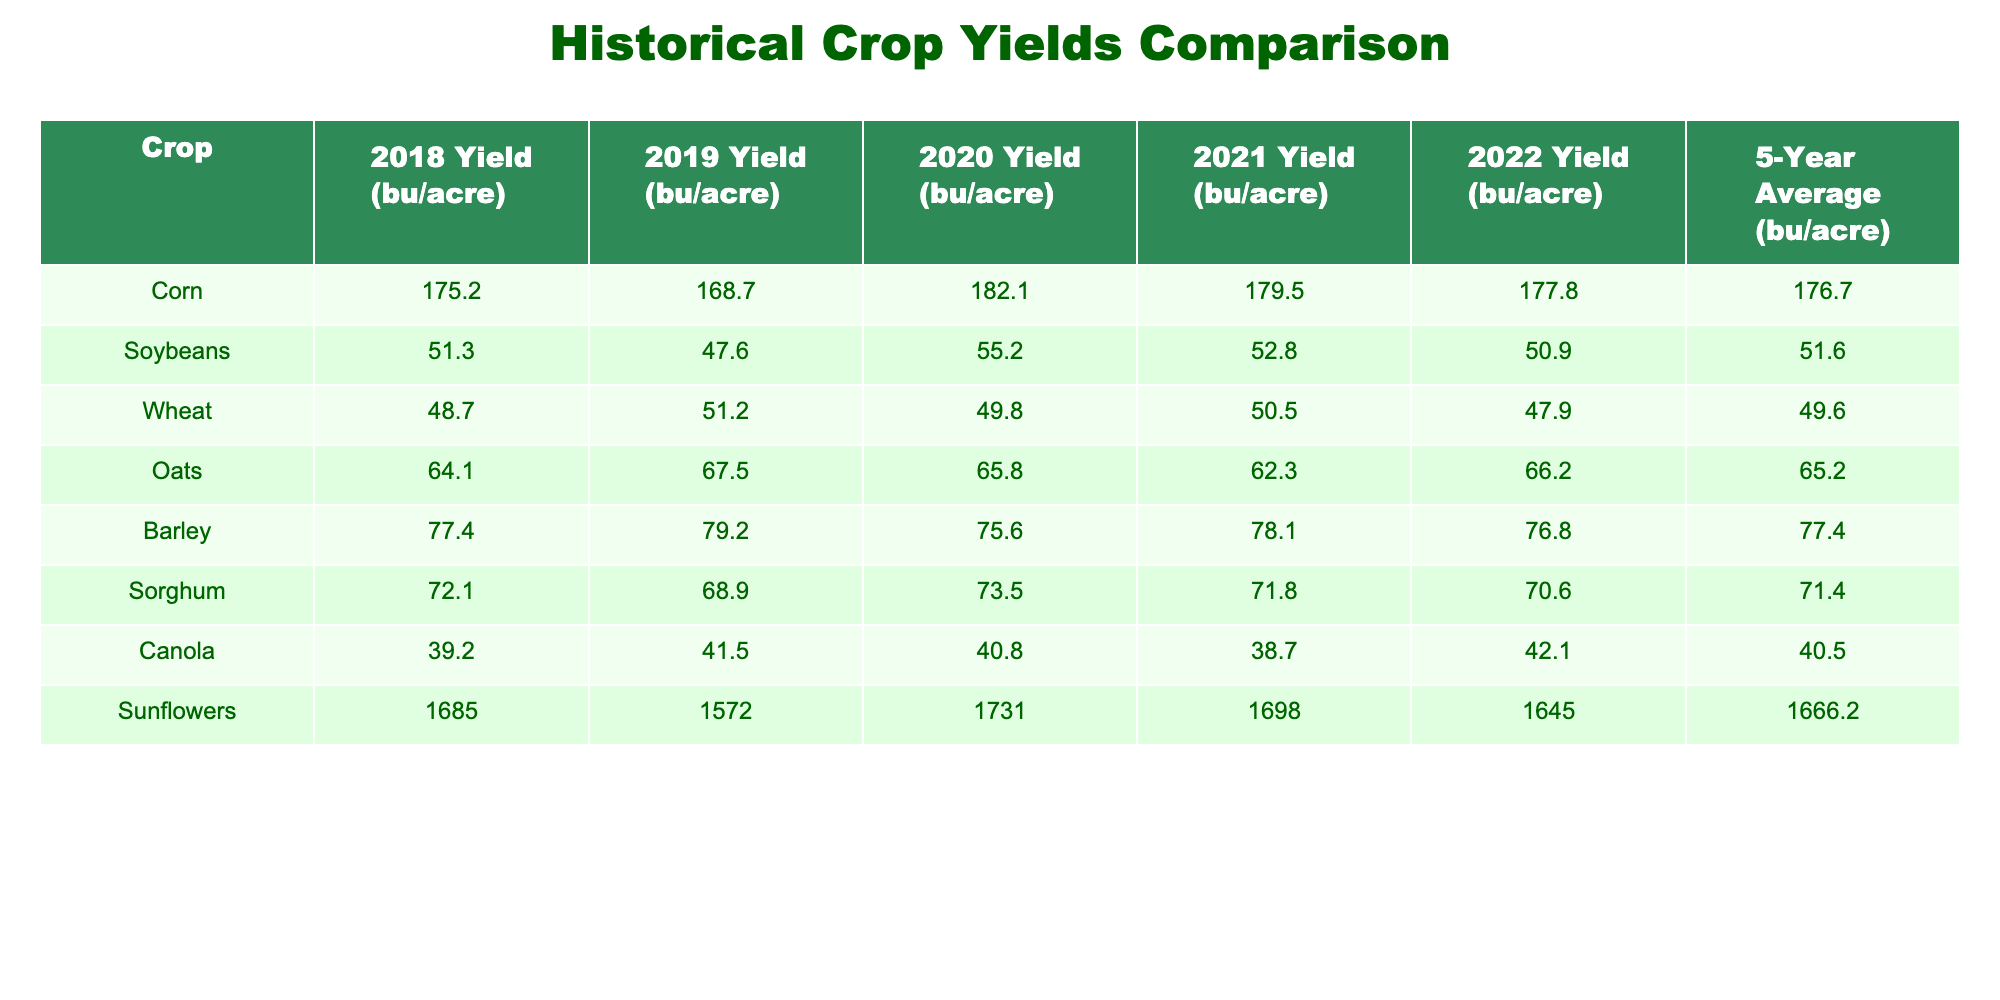What was the yield of corn in 2020? The table lists the yields for corn in each year. To find the yield in 2020, we look under the "2020 Yield (bu/acre)" column for corn, which shows 182.1.
Answer: 182.1 Which crop had the highest average yield over the 5 years? We need to compare the 5-Year Average yields for all crops listed in the table. The average yields are: Corn 176.7, Soybeans 51.6, Wheat 49.6, Oats 65.2, Barley 77.4, Sorghum 71.4, Canola 40.5, and Sunflowers 1666.2. Among these, Sunflowers have the highest yield at 1666.2.
Answer: Sunflowers Is the average yield of wheat greater than that of sorghum? The table shows the 5-Year Average yields: Wheat has 49.6, and Sorghum has 71.4. Since 49.6 is less than 71.4, the statement is false.
Answer: No What is the difference between the average yield of corn and the average yield of barley? From the table, the average yield for corn is 176.7, while for barley it is 77.4. To find the difference, we subtract the average yield of barley from that of corn: 176.7 - 77.4 = 99.3.
Answer: 99.3 In which year did soybeans have the lowest yield? To find the lowest yield for soybeans, we look at the annual yields in the table: 51.3 (2018), 47.6 (2019), 55.2 (2020), 52.8 (2021), and 50.9 (2022). The lowest yield is 47.6 in the year 2019.
Answer: 2019 What is the total yield of oats over the 5-year period? The yields for oats are: 64.1 (2018), 67.5 (2019), 65.8 (2020), 62.3 (2021), and 66.2 (2022). Summing these gives: 64.1 + 67.5 + 65.8 + 62.3 + 66.2 = 325.9.
Answer: 325.9 Did canola have a yield of more than 40 bu/acre in every year? We check the yields for canola: 39.2 (2018), 41.5 (2019), 40.8 (2020), 38.7 (2021), and 42.1 (2022). In 2018 and 2021, the yields were less than 40. Therefore, the statement is false.
Answer: No What was the change in yield for sunflowers from 2020 to 2021? The sunflower yields are 1731 (2020) and 1698 (2021). The change is calculated by subtracting 2021's yield from 2020's yield: 1731 - 1698 = 33.
Answer: 33 